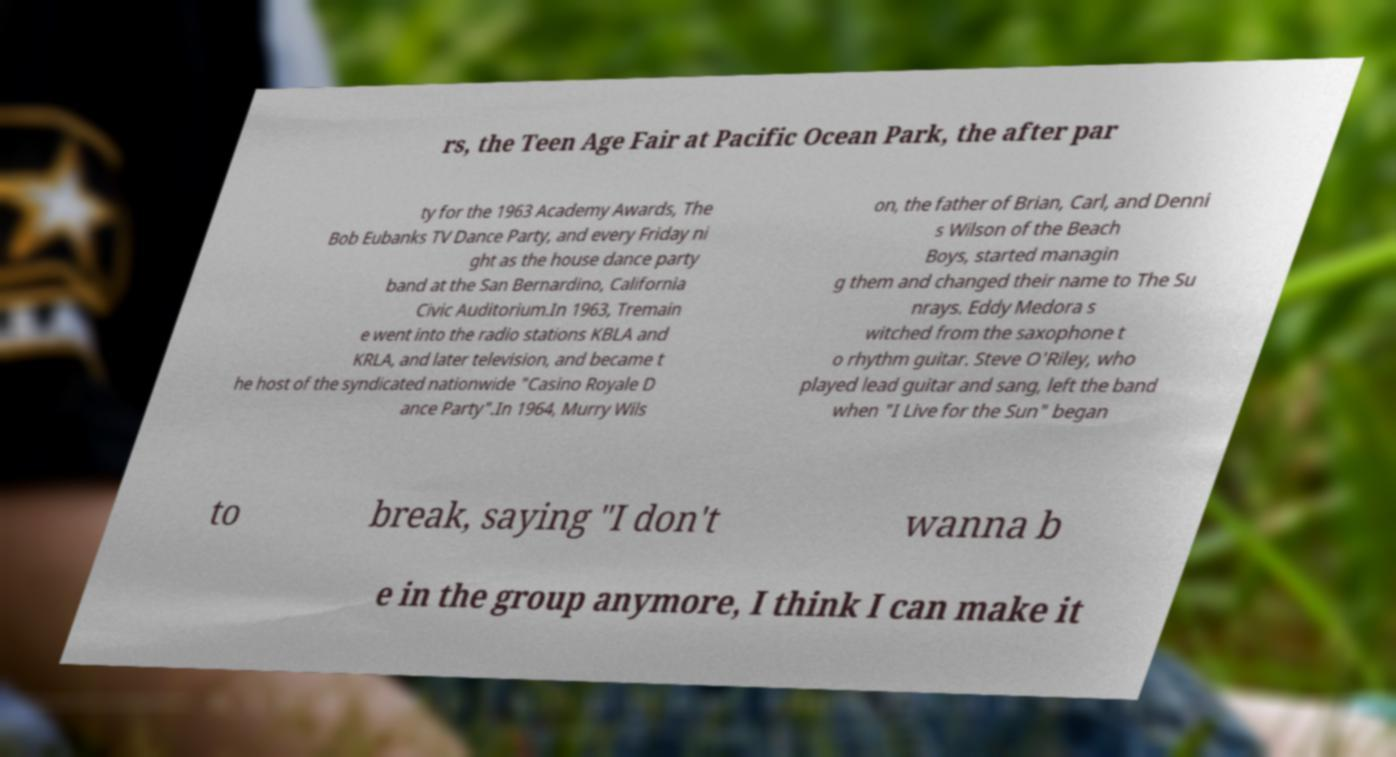Please read and relay the text visible in this image. What does it say? rs, the Teen Age Fair at Pacific Ocean Park, the after par ty for the 1963 Academy Awards, The Bob Eubanks TV Dance Party, and every Friday ni ght as the house dance party band at the San Bernardino, California Civic Auditorium.In 1963, Tremain e went into the radio stations KBLA and KRLA, and later television, and became t he host of the syndicated nationwide "Casino Royale D ance Party".In 1964, Murry Wils on, the father of Brian, Carl, and Denni s Wilson of the Beach Boys, started managin g them and changed their name to The Su nrays. Eddy Medora s witched from the saxophone t o rhythm guitar. Steve O'Riley, who played lead guitar and sang, left the band when "I Live for the Sun" began to break, saying "I don't wanna b e in the group anymore, I think I can make it 